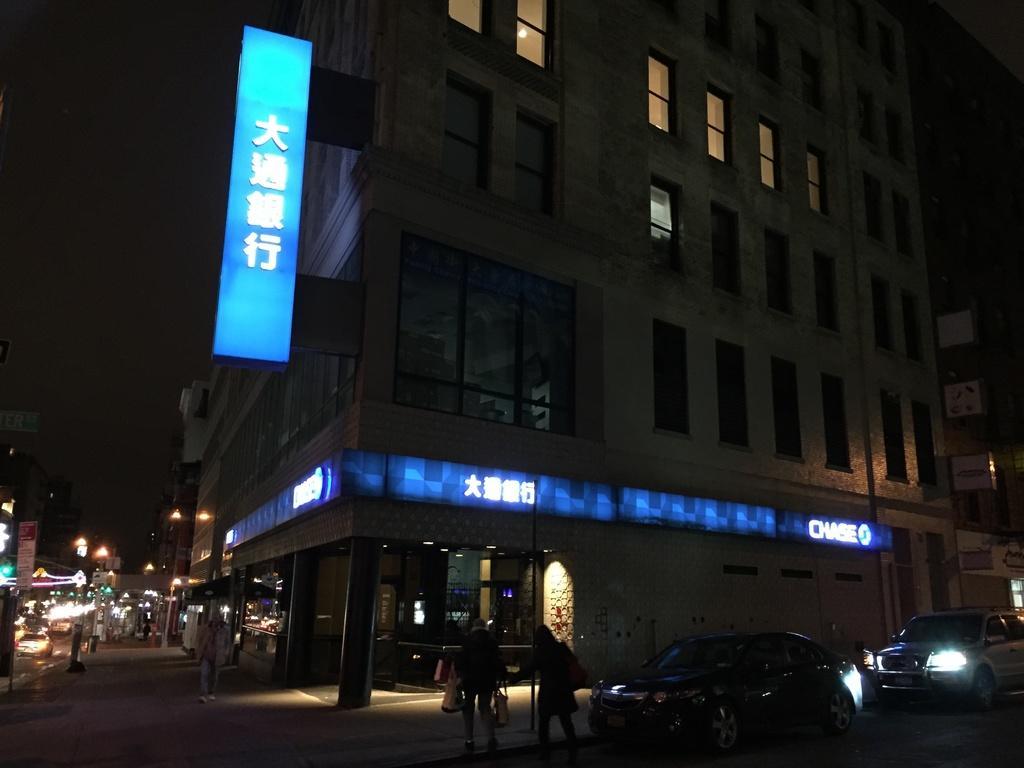Describe this image in one or two sentences. In this picture we can see a building and a hoarding in the front, there are some vehicles on the road, there are two persons walking in the middle, on the left side we can see some lights and a board, there is a dark background. 